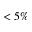Convert formula to latex. <formula><loc_0><loc_0><loc_500><loc_500>< 5 \%</formula> 